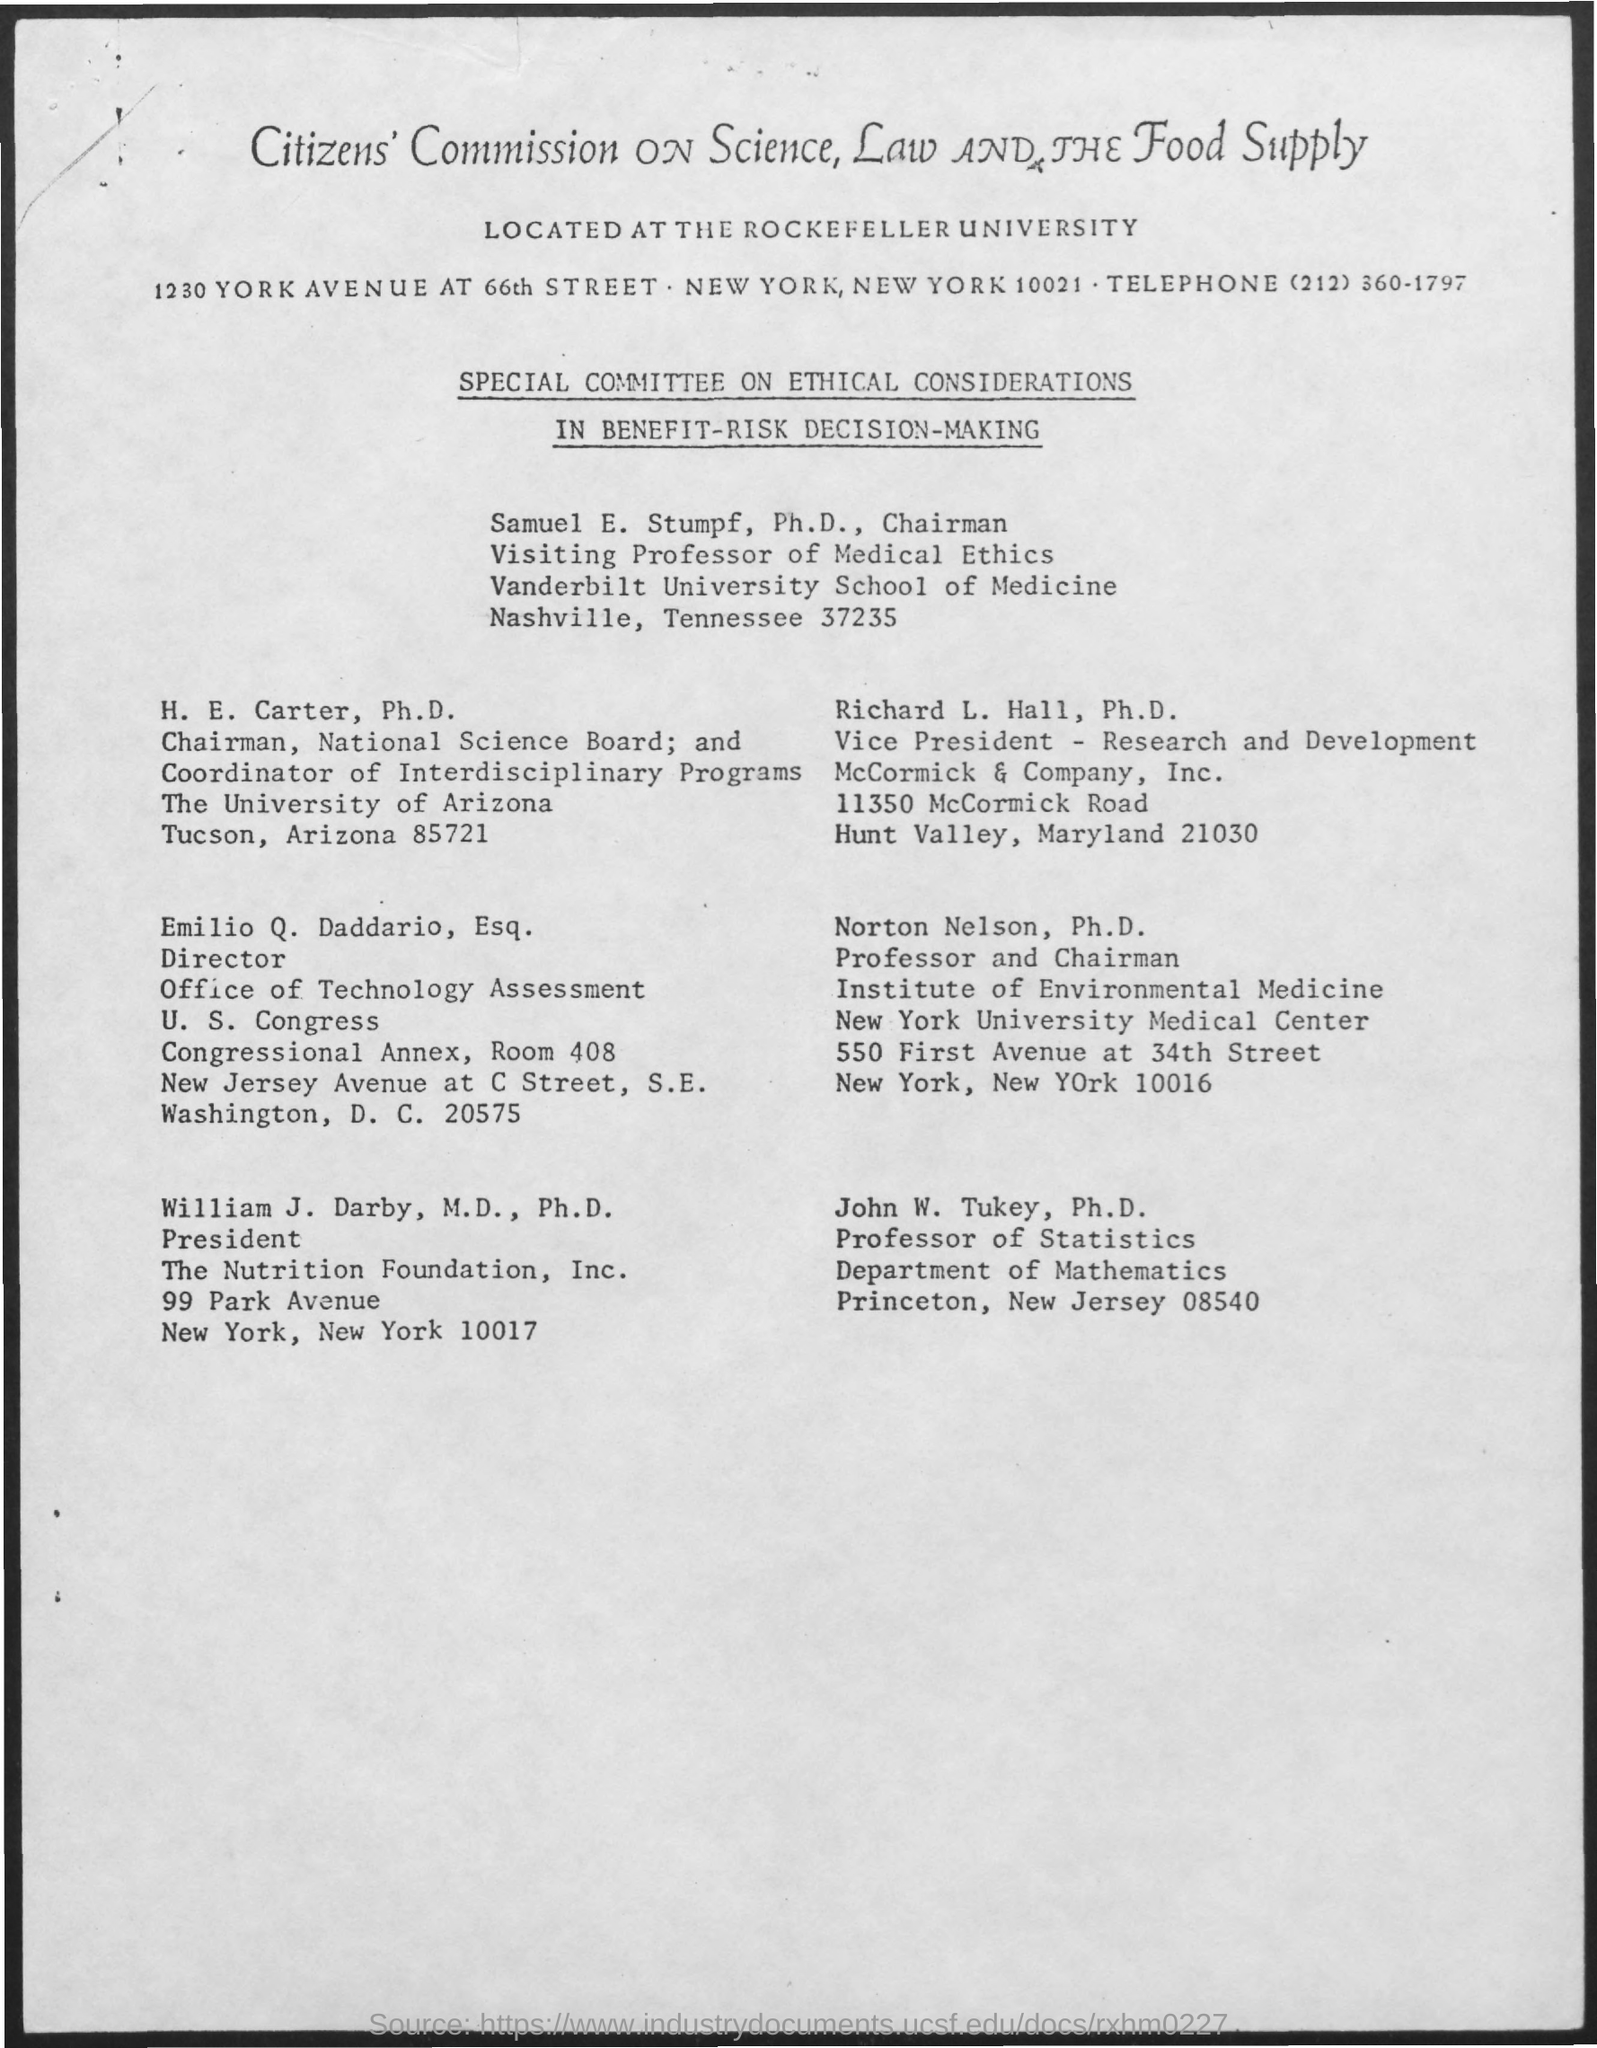what is the designation of john W. Turkey ?
 Professor of Statistics 